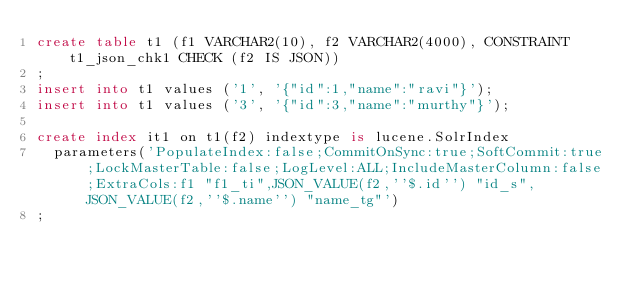Convert code to text. <code><loc_0><loc_0><loc_500><loc_500><_SQL_>create table t1 (f1 VARCHAR2(10), f2 VARCHAR2(4000), CONSTRAINT t1_json_chk1 CHECK (f2 IS JSON))
;
insert into t1 values ('1', '{"id":1,"name":"ravi"}');
insert into t1 values ('3', '{"id":3,"name":"murthy"}');

create index it1 on t1(f2) indextype is lucene.SolrIndex 
  parameters('PopulateIndex:false;CommitOnSync:true;SoftCommit:true;LockMasterTable:false;LogLevel:ALL;IncludeMasterColumn:false;ExtraCols:f1 "f1_ti",JSON_VALUE(f2,''$.id'') "id_s",JSON_VALUE(f2,''$.name'') "name_tg"')
;
</code> 